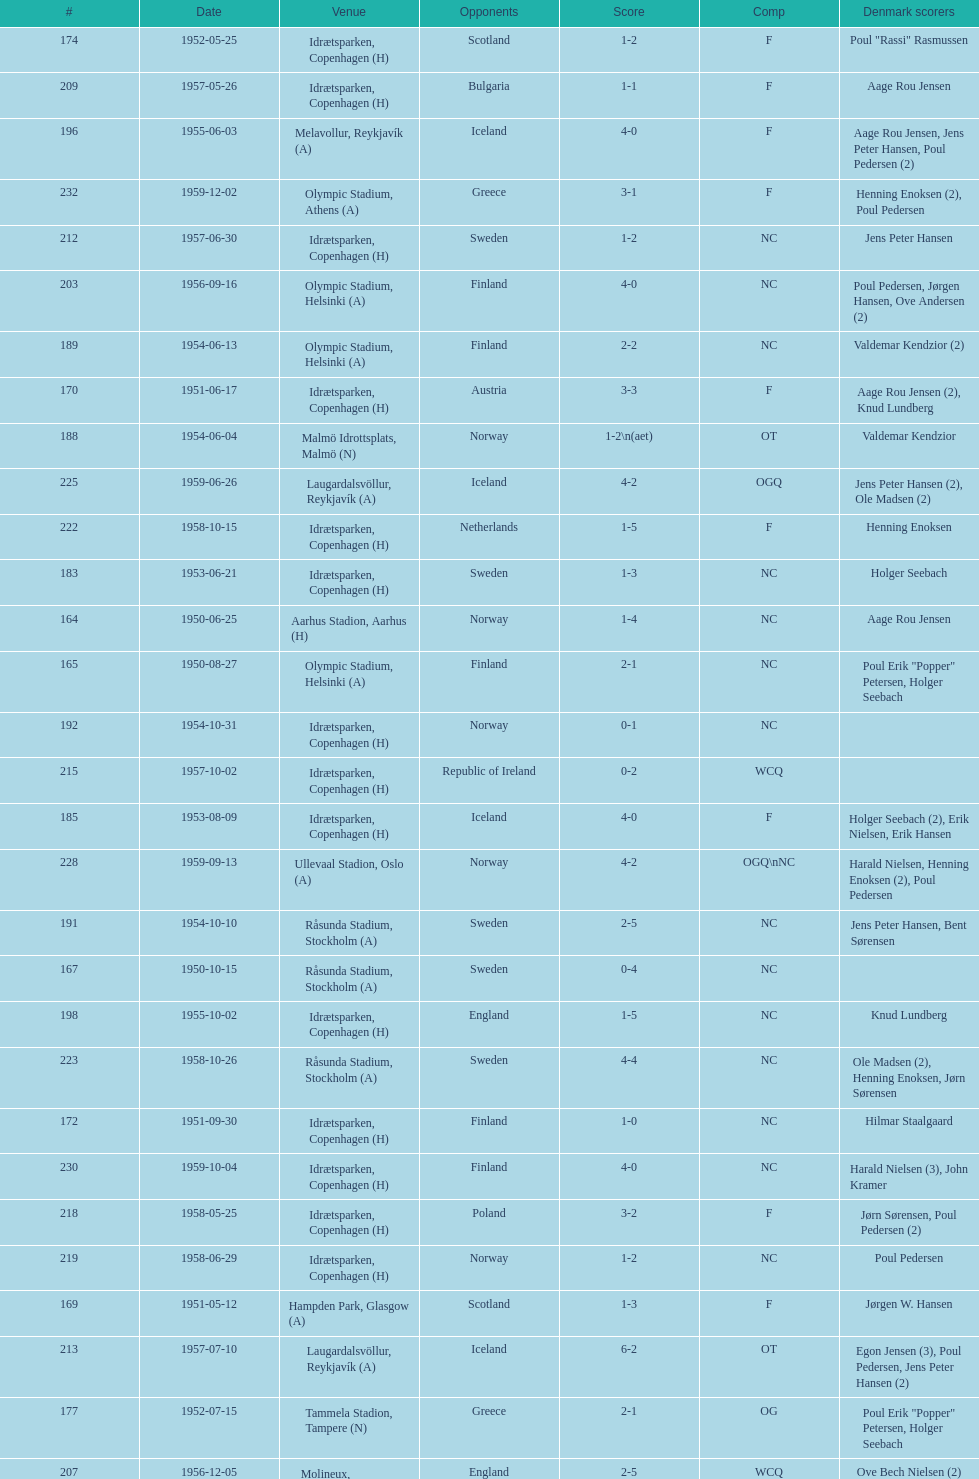Which total score was higher, game #163 or #181? 163. 